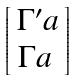<formula> <loc_0><loc_0><loc_500><loc_500>\begin{bmatrix} \, \Gamma ^ { \prime } a \, \\ \Gamma a \, \end{bmatrix}</formula> 